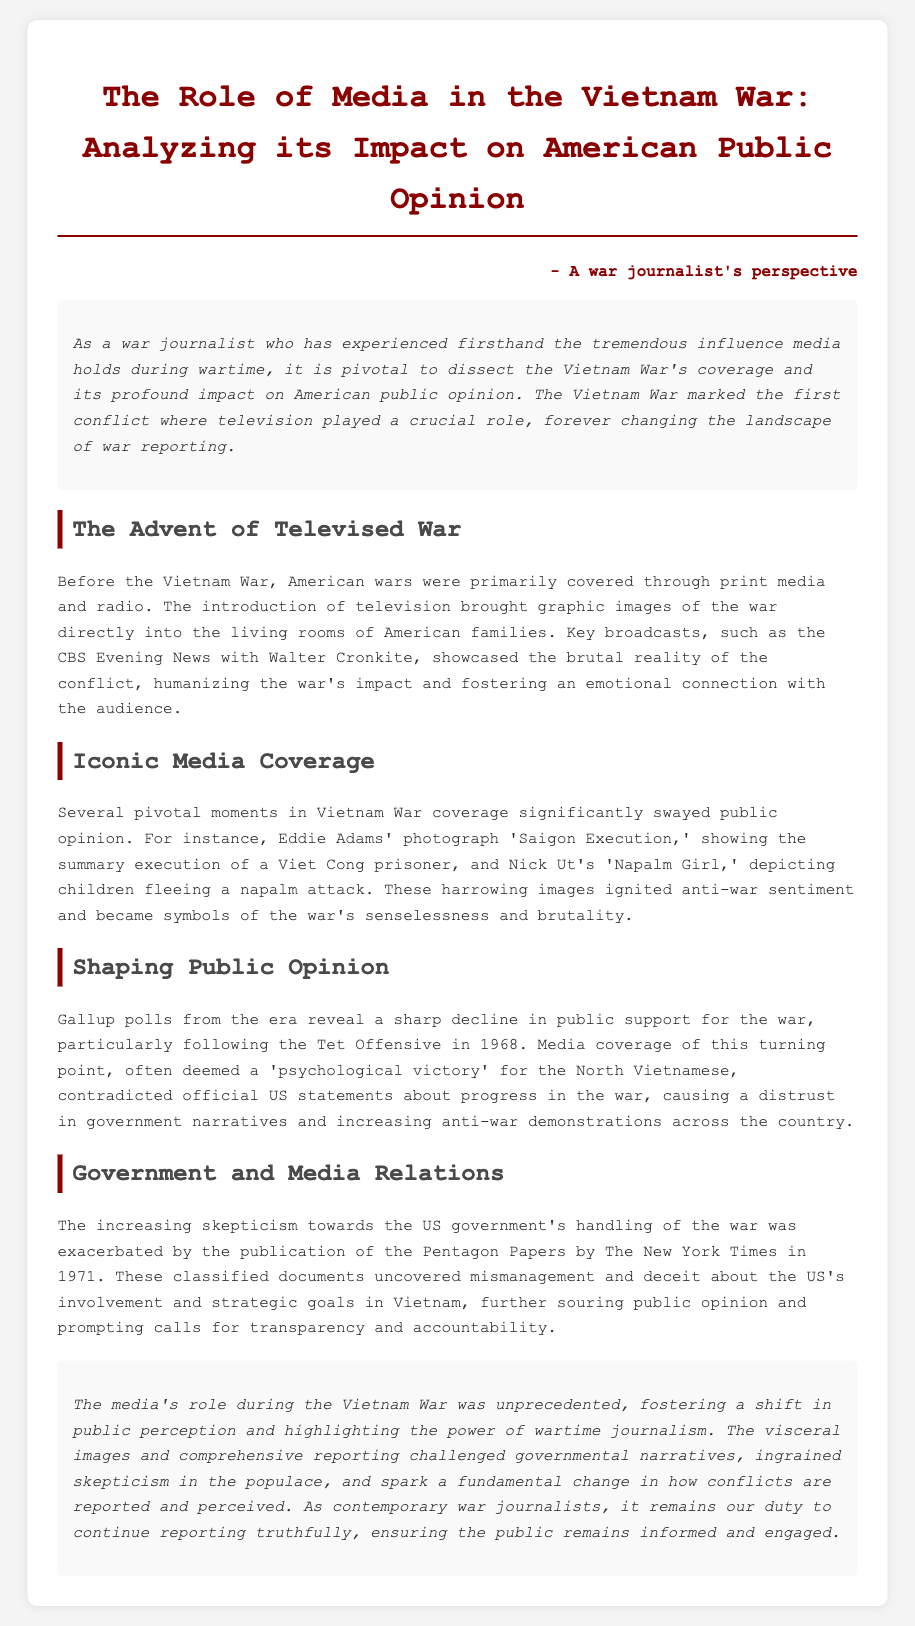What was the first conflict where television played a crucial role? The document states that the Vietnam War was the first conflict where television played a crucial role, marking a change in war reporting.
Answer: Vietnam War Who is associated with the photograph 'Saigon Execution'? The document credits photographer Eddie Adams with the iconic image 'Saigon Execution,' which depicts a Viet Cong execution.
Answer: Eddie Adams What year did the Tet Offensive occur? According to the document, Gallup polls show a decline in public support for the war particularly following the Tet Offensive in 1968.
Answer: 1968 What major publication released the Pentagon Papers? The document mentions that The New York Times published the Pentagon Papers, uncovering government mismanagement regarding the war.
Answer: The New York Times What was a significant effect of the media coverage during the Vietnam War? The section on shaping public opinion explains that media coverage led to a decline in public support for the war and increased anti-war demonstrations.
Answer: Decline in public support What pivotal images sparked anti-war sentiment during the Vietnam War? The document cites two significant photographs, 'Saigon Execution' and 'Napalm Girl,' that became symbols of the war's brutality.
Answer: 'Saigon Execution' and 'Napalm Girl' Why did skepticism towards the US government increase during the Vietnam War? The document explains that skepticism rose after the release of the Pentagon Papers, revealing mismanagement and deceit about the war.
Answer: Pentagon Papers What emotional connection did televised broadcasts create? The section on the advent of televised war describes how broadcasts showcased the brutal reality of the conflict, fostering an emotional connection with the audience.
Answer: Emotional connection 